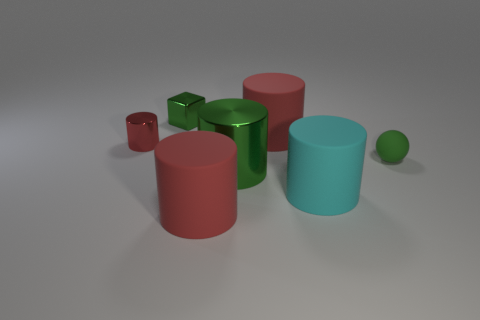Subtract all purple blocks. How many red cylinders are left? 3 Subtract all cyan cylinders. How many cylinders are left? 4 Subtract all tiny red metallic cylinders. How many cylinders are left? 4 Add 2 tiny metallic cubes. How many objects exist? 9 Subtract all blue cylinders. Subtract all red blocks. How many cylinders are left? 5 Subtract all spheres. How many objects are left? 6 Add 7 balls. How many balls are left? 8 Add 7 large rubber cylinders. How many large rubber cylinders exist? 10 Subtract 1 green blocks. How many objects are left? 6 Subtract all red objects. Subtract all purple shiny things. How many objects are left? 4 